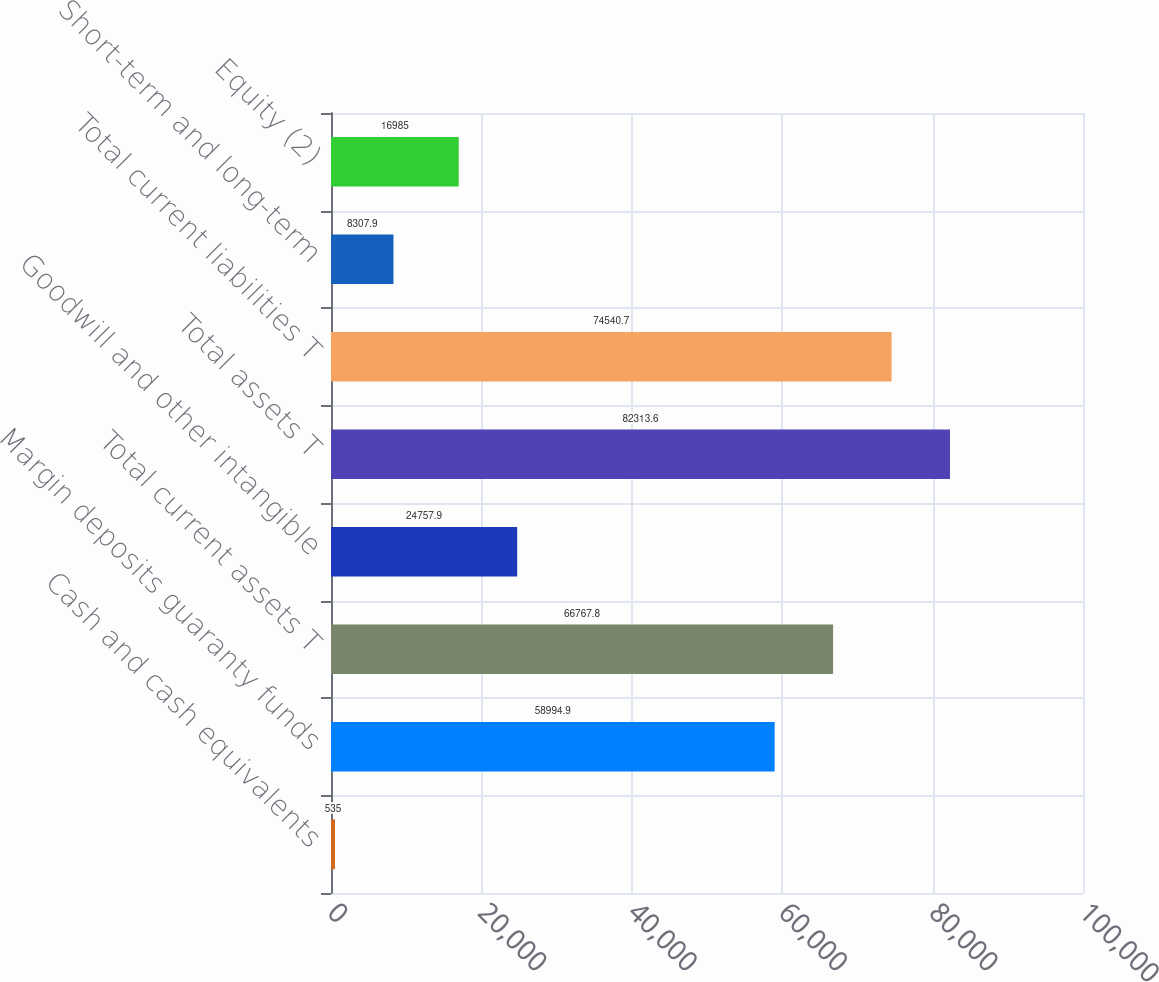Convert chart to OTSL. <chart><loc_0><loc_0><loc_500><loc_500><bar_chart><fcel>Cash and cash equivalents<fcel>Margin deposits guaranty funds<fcel>Total current assets T<fcel>Goodwill and other intangible<fcel>Total assets T<fcel>Total current liabilities T<fcel>Short-term and long-term<fcel>Equity (2)<nl><fcel>535<fcel>58994.9<fcel>66767.8<fcel>24757.9<fcel>82313.6<fcel>74540.7<fcel>8307.9<fcel>16985<nl></chart> 